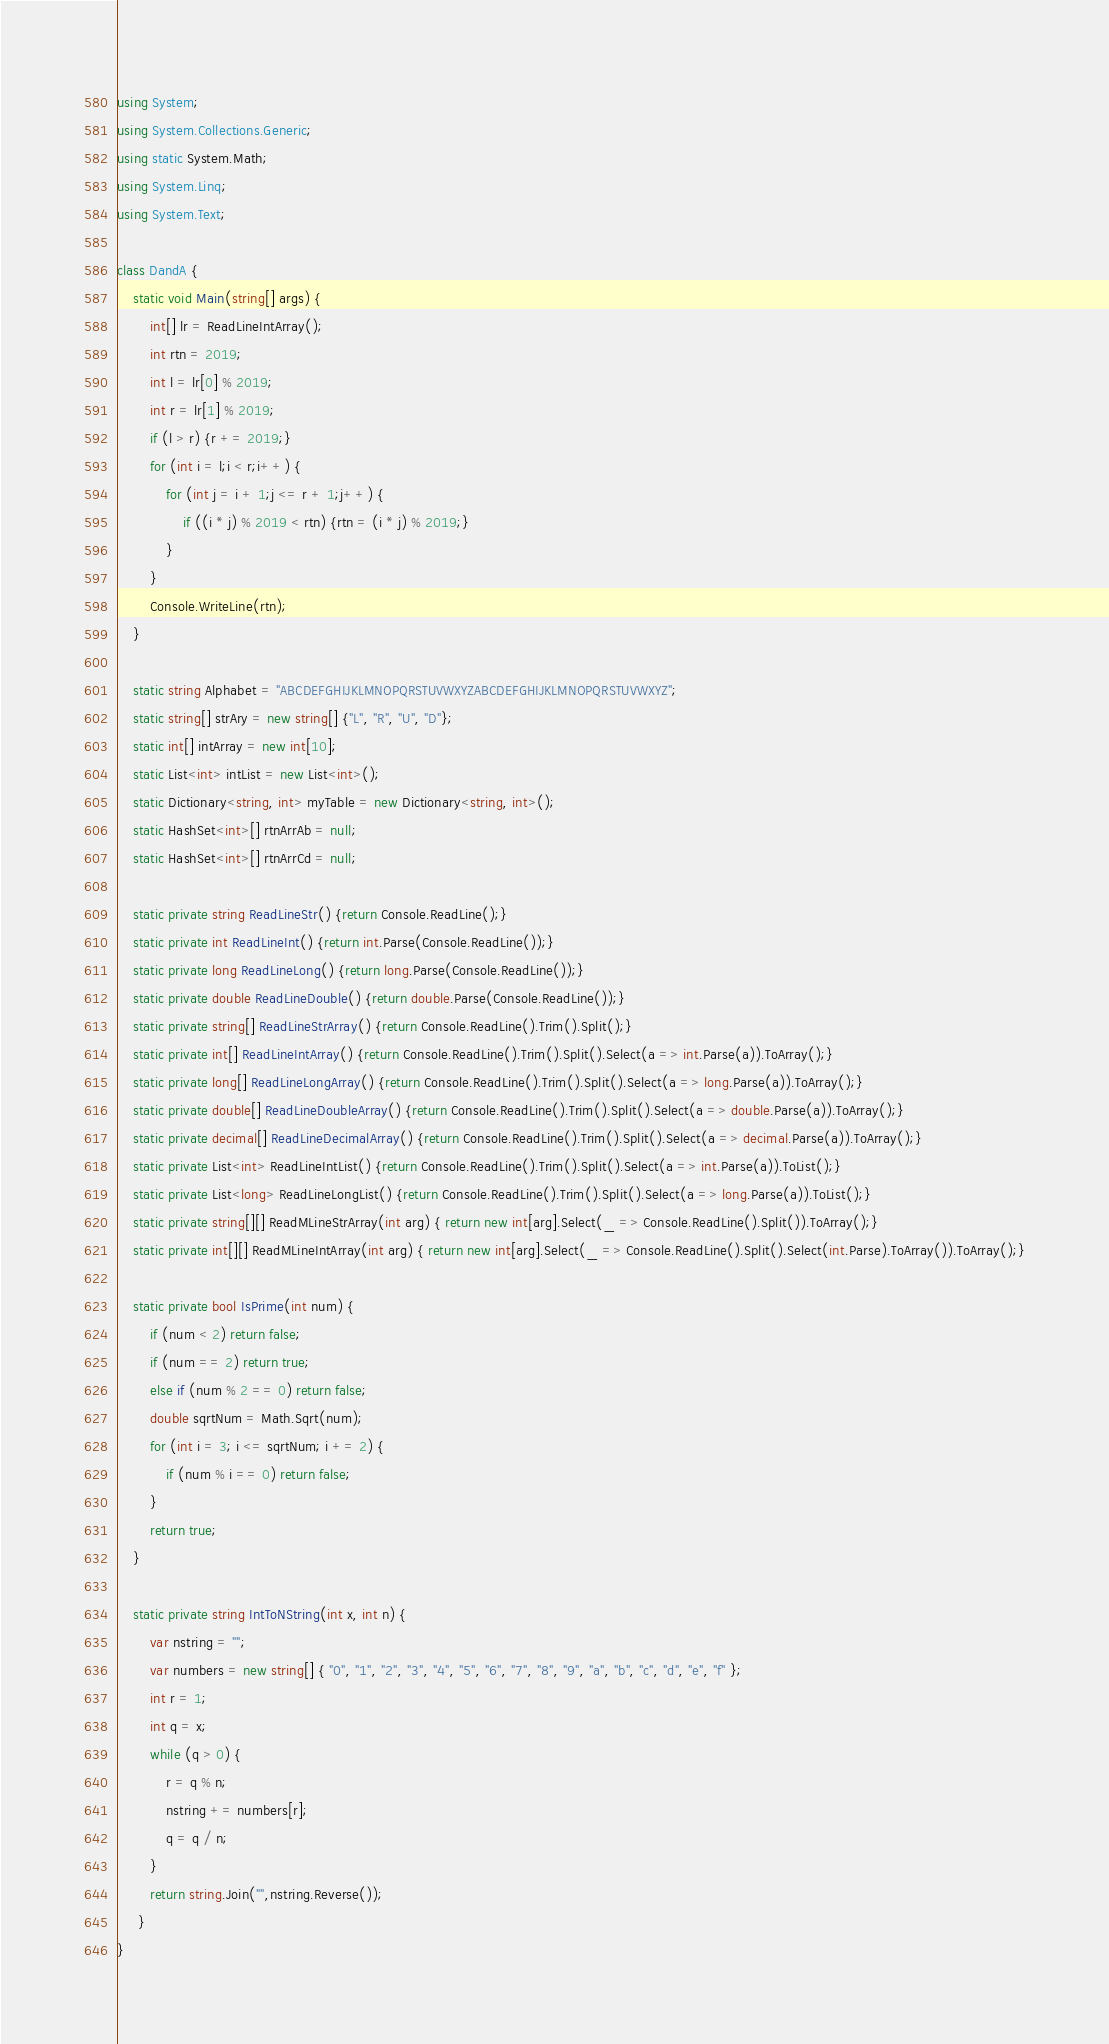<code> <loc_0><loc_0><loc_500><loc_500><_C#_>using System;
using System.Collections.Generic;
using static System.Math;
using System.Linq;
using System.Text;
 
class DandA {
    static void Main(string[] args) {
        int[] lr = ReadLineIntArray();
        int rtn = 2019;
        int l = lr[0] % 2019;
        int r = lr[1] % 2019;
        if (l > r) {r += 2019;}
        for (int i = l;i < r;i++) {
            for (int j = i + 1;j <= r + 1;j++) {
                if ((i * j) % 2019 < rtn) {rtn = (i * j) % 2019;}
            }
        }
        Console.WriteLine(rtn);
    }
 
    static string Alphabet = "ABCDEFGHIJKLMNOPQRSTUVWXYZABCDEFGHIJKLMNOPQRSTUVWXYZ";
    static string[] strAry = new string[] {"L", "R", "U", "D"};
    static int[] intArray = new int[10];
    static List<int> intList = new List<int>();
    static Dictionary<string, int> myTable = new Dictionary<string, int>();
    static HashSet<int>[] rtnArrAb = null;
    static HashSet<int>[] rtnArrCd = null;
  
    static private string ReadLineStr() {return Console.ReadLine();}
    static private int ReadLineInt() {return int.Parse(Console.ReadLine());}
    static private long ReadLineLong() {return long.Parse(Console.ReadLine());}
    static private double ReadLineDouble() {return double.Parse(Console.ReadLine());}
    static private string[] ReadLineStrArray() {return Console.ReadLine().Trim().Split();}
    static private int[] ReadLineIntArray() {return Console.ReadLine().Trim().Split().Select(a => int.Parse(a)).ToArray();}
    static private long[] ReadLineLongArray() {return Console.ReadLine().Trim().Split().Select(a => long.Parse(a)).ToArray();}
    static private double[] ReadLineDoubleArray() {return Console.ReadLine().Trim().Split().Select(a => double.Parse(a)).ToArray();}
    static private decimal[] ReadLineDecimalArray() {return Console.ReadLine().Trim().Split().Select(a => decimal.Parse(a)).ToArray();}
    static private List<int> ReadLineIntList() {return Console.ReadLine().Trim().Split().Select(a => int.Parse(a)).ToList();}
    static private List<long> ReadLineLongList() {return Console.ReadLine().Trim().Split().Select(a => long.Parse(a)).ToList();}
    static private string[][] ReadMLineStrArray(int arg) { return new int[arg].Select(_ => Console.ReadLine().Split()).ToArray();}
    static private int[][] ReadMLineIntArray(int arg) { return new int[arg].Select(_ => Console.ReadLine().Split().Select(int.Parse).ToArray()).ToArray();}
 
    static private bool IsPrime(int num) {
        if (num < 2) return false;
        if (num == 2) return true;
        else if (num % 2 == 0) return false;
        double sqrtNum = Math.Sqrt(num);
        for (int i = 3; i <= sqrtNum; i += 2) {
            if (num % i == 0) return false;
        }
        return true;
    }
  
    static private string IntToNString(int x, int n) {
        var nstring = "";
        var numbers = new string[] { "0", "1", "2", "3", "4", "5", "6", "7", "8", "9", "a", "b", "c", "d", "e", "f" };
        int r = 1;
        int q = x;
        while (q > 0) {
            r = q % n;
            nstring += numbers[r];
            q = q / n;
        }
        return string.Join("",nstring.Reverse());
     }
}</code> 